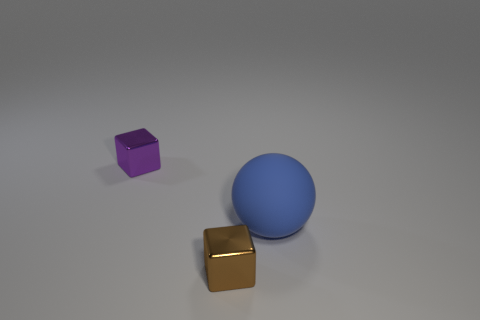Is there another tiny thing of the same shape as the brown object?
Keep it short and to the point. Yes. What material is the ball?
Your answer should be very brief. Rubber. There is a blue matte thing in front of the purple block; what is its size?
Make the answer very short. Large. Are there any cubes that are behind the cube that is in front of the cube that is behind the big blue matte thing?
Make the answer very short. Yes. What number of spheres are either cyan objects or big blue matte objects?
Ensure brevity in your answer.  1. What is the shape of the metallic thing behind the shiny object in front of the big rubber sphere?
Provide a succinct answer. Cube. What size is the matte sphere that is behind the brown metal cube in front of the purple thing left of the small brown shiny thing?
Make the answer very short. Large. Is the brown metal cube the same size as the purple shiny cube?
Make the answer very short. Yes. What number of objects are either large blue things or objects?
Offer a very short reply. 3. What is the size of the thing that is behind the blue rubber object right of the tiny purple shiny object?
Offer a terse response. Small. 